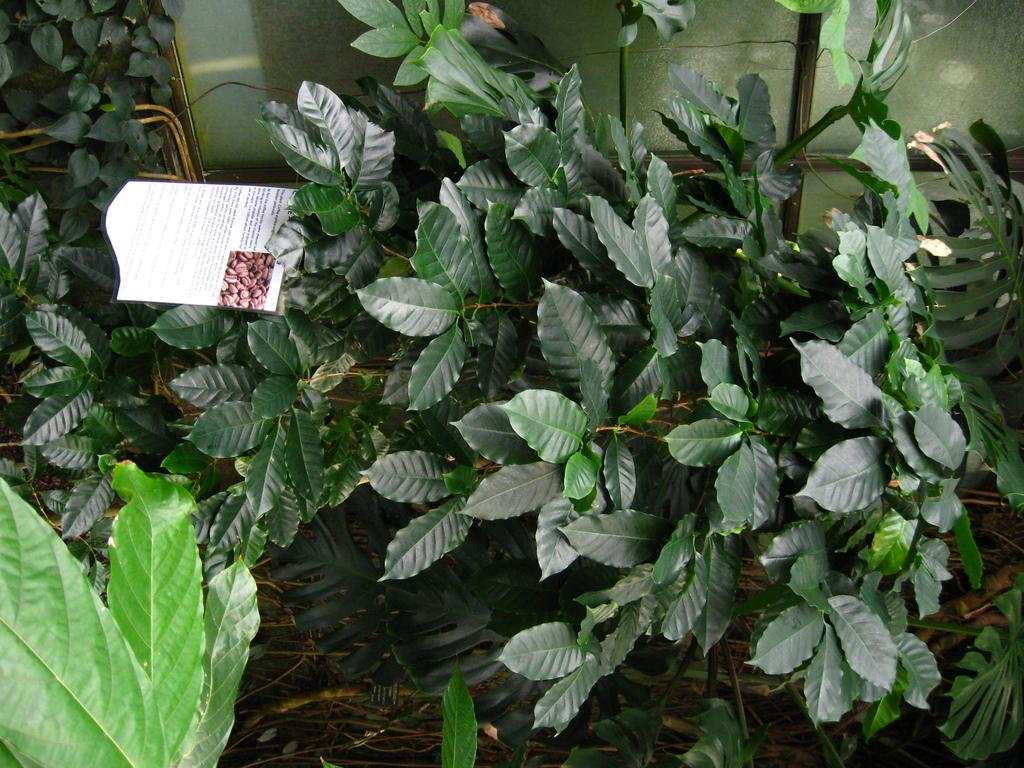What type of natural elements can be seen in the image? There are leaves in the image. What man-made object is present in the image? A: There is an information card in the image. What type of silk material is used to make the flock of birds in the image? There are no birds or silk material present in the image; it only contains leaves and an information card. 